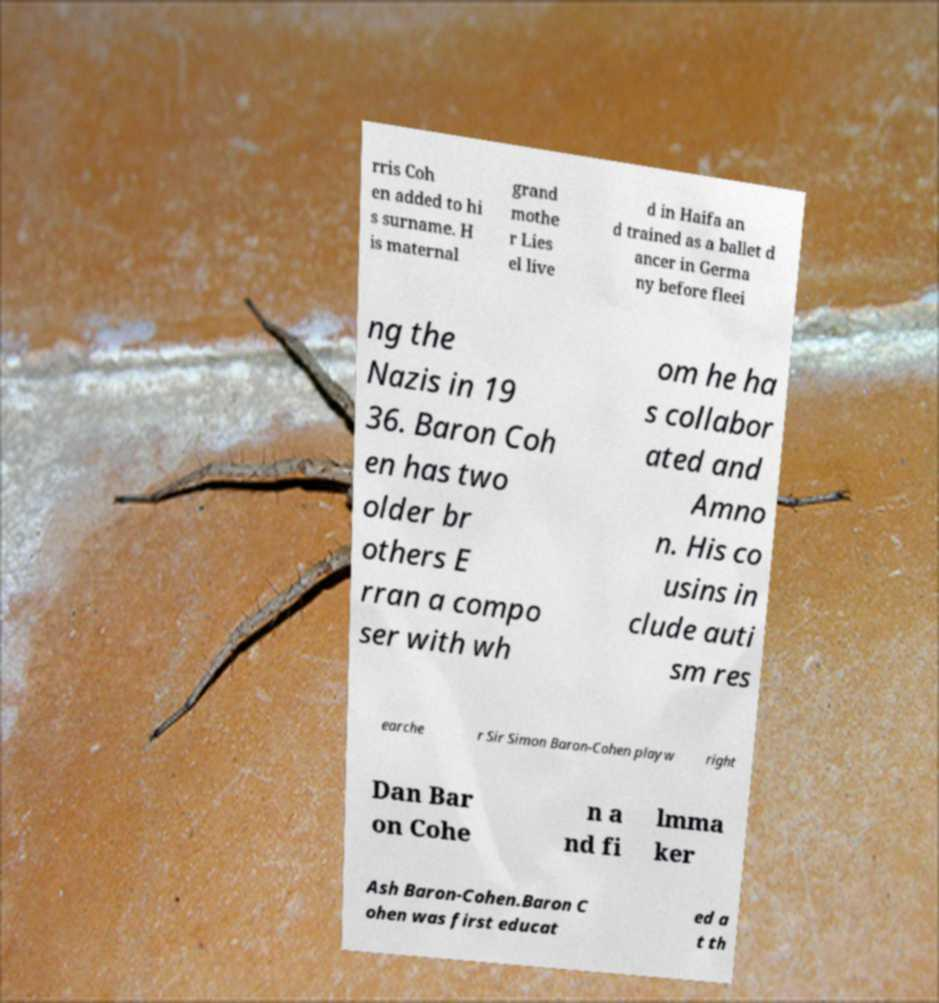For documentation purposes, I need the text within this image transcribed. Could you provide that? rris Coh en added to hi s surname. H is maternal grand mothe r Lies el live d in Haifa an d trained as a ballet d ancer in Germa ny before fleei ng the Nazis in 19 36. Baron Coh en has two older br others E rran a compo ser with wh om he ha s collabor ated and Amno n. His co usins in clude auti sm res earche r Sir Simon Baron-Cohen playw right Dan Bar on Cohe n a nd fi lmma ker Ash Baron-Cohen.Baron C ohen was first educat ed a t th 